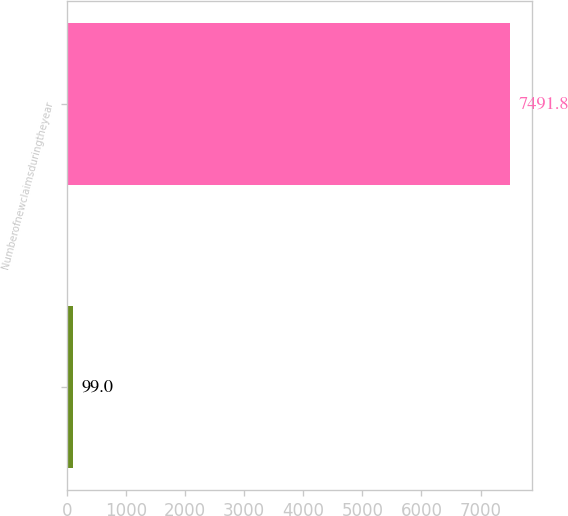Convert chart to OTSL. <chart><loc_0><loc_0><loc_500><loc_500><bar_chart><ecel><fcel>Numberofnewclaimsduringtheyear<nl><fcel>99<fcel>7491.8<nl></chart> 